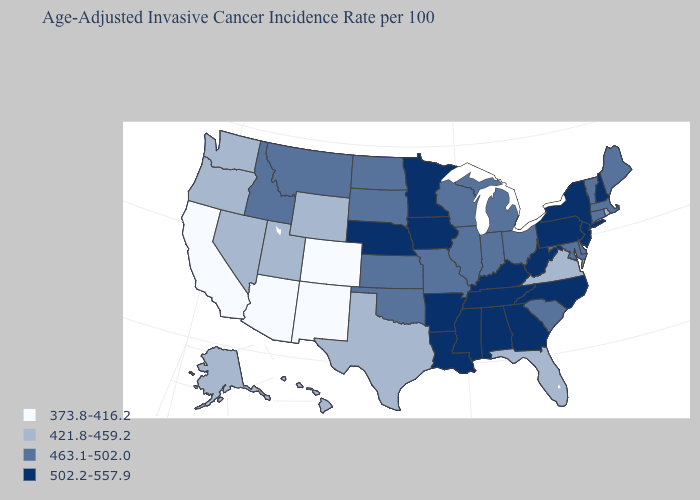Name the states that have a value in the range 421.8-459.2?
Be succinct. Alaska, Florida, Hawaii, Nevada, Oregon, Rhode Island, Texas, Utah, Virginia, Washington, Wyoming. Among the states that border Texas , does New Mexico have the lowest value?
Write a very short answer. Yes. Name the states that have a value in the range 373.8-416.2?
Answer briefly. Arizona, California, Colorado, New Mexico. Which states have the highest value in the USA?
Answer briefly. Alabama, Arkansas, Georgia, Iowa, Kentucky, Louisiana, Minnesota, Mississippi, Nebraska, New Hampshire, New Jersey, New York, North Carolina, Pennsylvania, Tennessee, West Virginia. What is the value of Ohio?
Keep it brief. 463.1-502.0. Name the states that have a value in the range 502.2-557.9?
Keep it brief. Alabama, Arkansas, Georgia, Iowa, Kentucky, Louisiana, Minnesota, Mississippi, Nebraska, New Hampshire, New Jersey, New York, North Carolina, Pennsylvania, Tennessee, West Virginia. What is the value of Rhode Island?
Give a very brief answer. 421.8-459.2. How many symbols are there in the legend?
Keep it brief. 4. Does the first symbol in the legend represent the smallest category?
Answer briefly. Yes. Does North Dakota have the lowest value in the USA?
Quick response, please. No. What is the highest value in the USA?
Quick response, please. 502.2-557.9. Does the first symbol in the legend represent the smallest category?
Answer briefly. Yes. Which states have the highest value in the USA?
Quick response, please. Alabama, Arkansas, Georgia, Iowa, Kentucky, Louisiana, Minnesota, Mississippi, Nebraska, New Hampshire, New Jersey, New York, North Carolina, Pennsylvania, Tennessee, West Virginia. Name the states that have a value in the range 421.8-459.2?
Quick response, please. Alaska, Florida, Hawaii, Nevada, Oregon, Rhode Island, Texas, Utah, Virginia, Washington, Wyoming. Does the first symbol in the legend represent the smallest category?
Be succinct. Yes. 